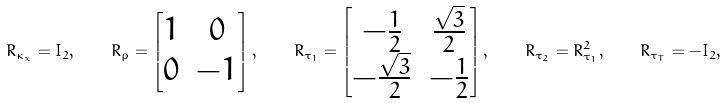Convert formula to latex. <formula><loc_0><loc_0><loc_500><loc_500>R _ { \kappa _ { x } } = I _ { 2 } , \quad R _ { \rho } = \begin{bmatrix} 1 & 0 \\ 0 & - 1 \end{bmatrix} , \quad R _ { \tau _ { 1 } } = \begin{bmatrix} - \frac { 1 } { 2 } & \frac { \sqrt { 3 } } { 2 } \\ - \frac { \sqrt { 3 } } { 2 } & - \frac { 1 } { 2 } \end{bmatrix} , \quad R _ { \tau _ { 2 } } = R _ { \tau _ { 1 } } ^ { 2 } , \quad R _ { \tau _ { T } } = - I _ { 2 } ,</formula> 